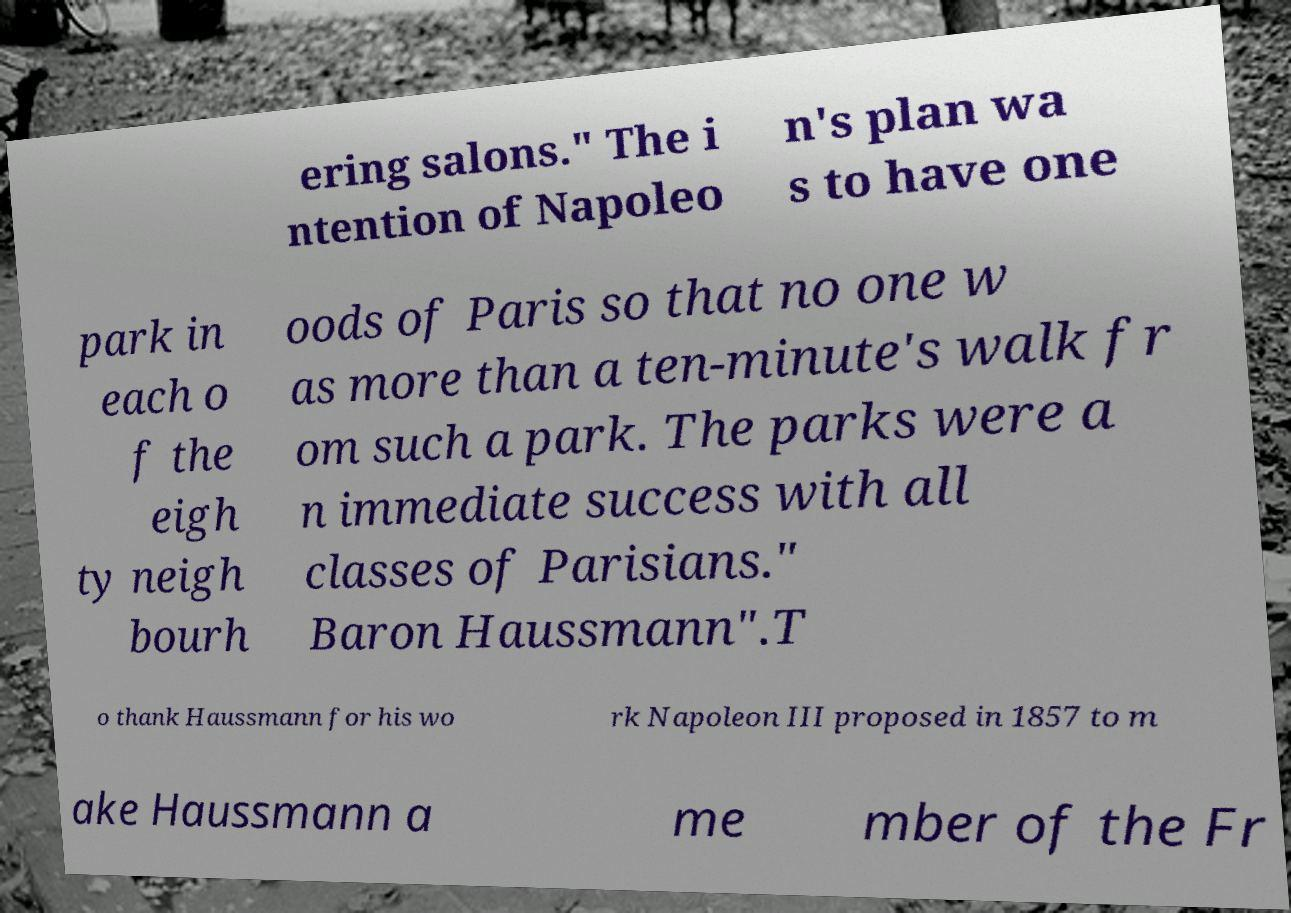Can you accurately transcribe the text from the provided image for me? ering salons." The i ntention of Napoleo n's plan wa s to have one park in each o f the eigh ty neigh bourh oods of Paris so that no one w as more than a ten-minute's walk fr om such a park. The parks were a n immediate success with all classes of Parisians." Baron Haussmann".T o thank Haussmann for his wo rk Napoleon III proposed in 1857 to m ake Haussmann a me mber of the Fr 